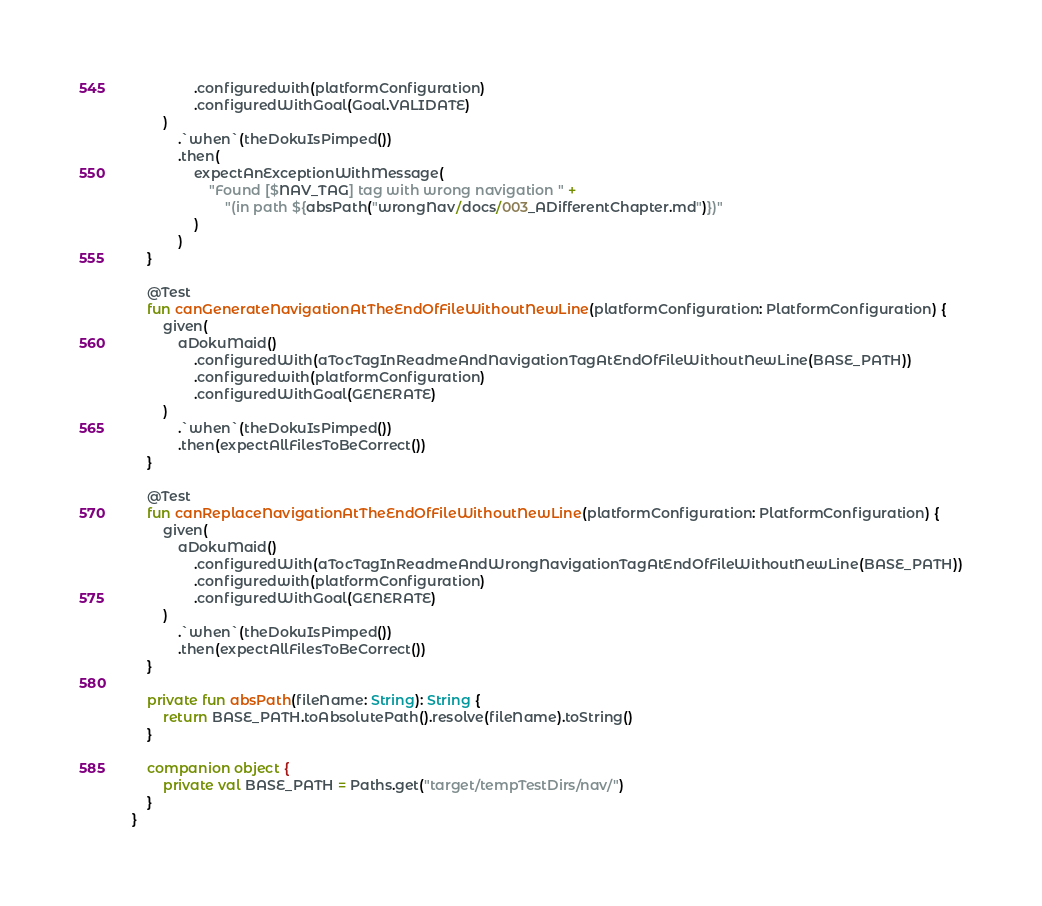<code> <loc_0><loc_0><loc_500><loc_500><_Kotlin_>                .configuredwith(platformConfiguration)
                .configuredWithGoal(Goal.VALIDATE)
        )
            .`when`(theDokuIsPimped())
            .then(
                expectAnExceptionWithMessage(
                    "Found [$NAV_TAG] tag with wrong navigation " +
                        "(in path ${absPath("wrongNav/docs/003_ADifferentChapter.md")})"
                )
            )
    }

    @Test
    fun canGenerateNavigationAtTheEndOfFileWithoutNewLine(platformConfiguration: PlatformConfiguration) {
        given(
            aDokuMaid()
                .configuredWith(aTocTagInReadmeAndNavigationTagAtEndOfFileWithoutNewLine(BASE_PATH))
                .configuredwith(platformConfiguration)
                .configuredWithGoal(GENERATE)
        )
            .`when`(theDokuIsPimped())
            .then(expectAllFilesToBeCorrect())
    }

    @Test
    fun canReplaceNavigationAtTheEndOfFileWithoutNewLine(platformConfiguration: PlatformConfiguration) {
        given(
            aDokuMaid()
                .configuredWith(aTocTagInReadmeAndWrongNavigationTagAtEndOfFileWithoutNewLine(BASE_PATH))
                .configuredwith(platformConfiguration)
                .configuredWithGoal(GENERATE)
        )
            .`when`(theDokuIsPimped())
            .then(expectAllFilesToBeCorrect())
    }

    private fun absPath(fileName: String): String {
        return BASE_PATH.toAbsolutePath().resolve(fileName).toString()
    }

    companion object {
        private val BASE_PATH = Paths.get("target/tempTestDirs/nav/")
    }
}
</code> 